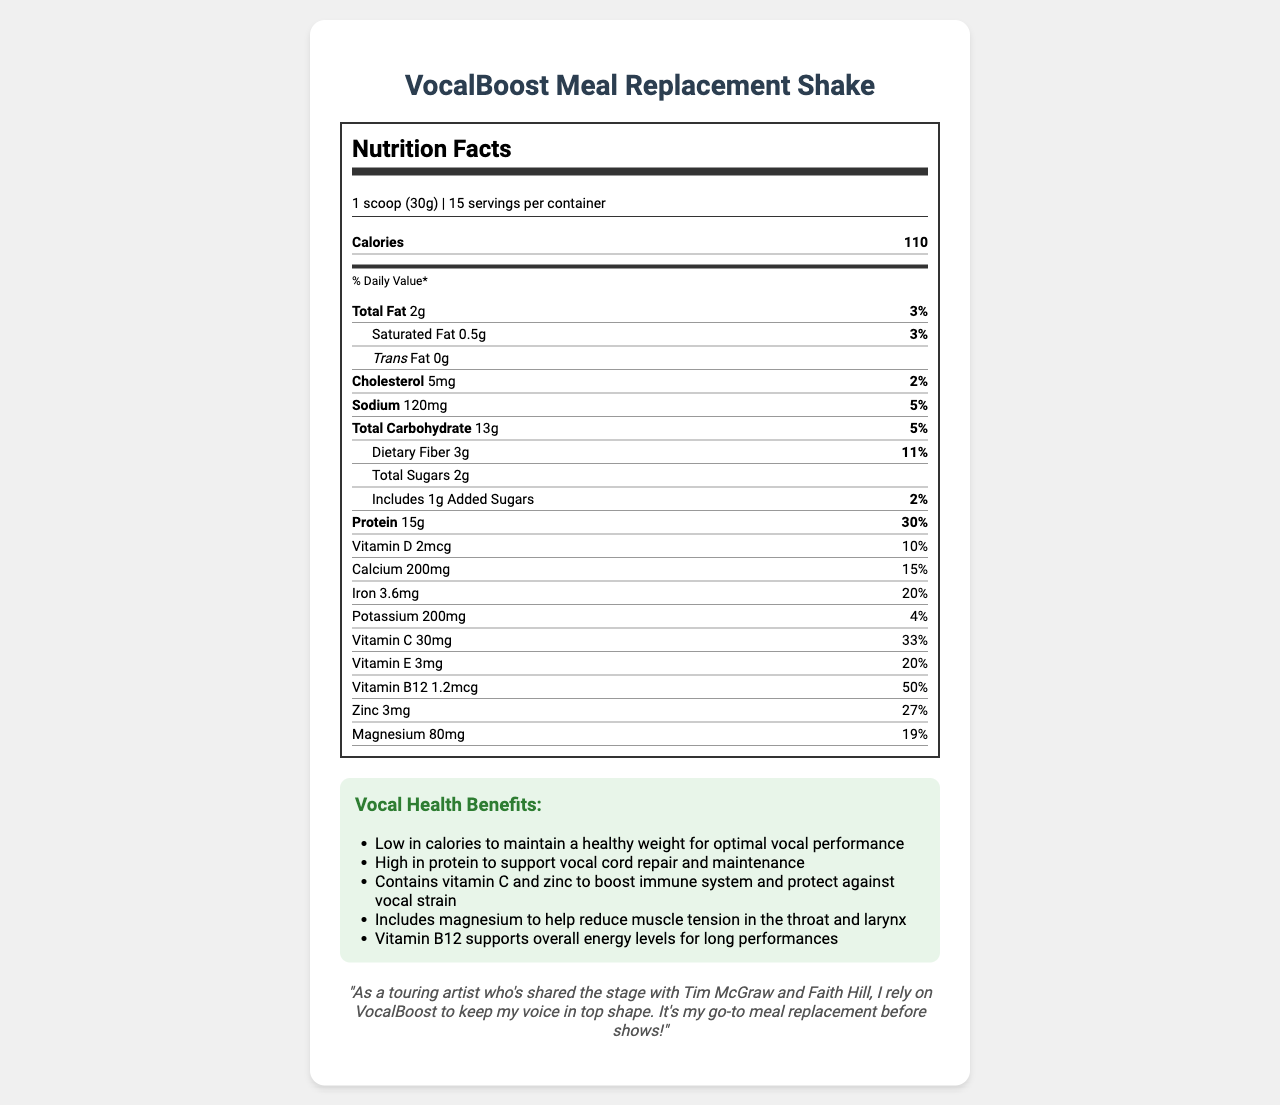what is the product name? The product name is clearly stated at the beginning of the document.
Answer: VocalBoost Meal Replacement Shake how many servings are in each container? The document specifies that there are 15 servings per container.
Answer: 15 servings what is the serving size? The serving size is mentioned as "1 scoop (30g)" in the document.
Answer: 1 scoop (30g) how many calories are in one serving? The document lists 110 calories per serving.
Answer: 110 calories what is the amount of protein in one serving? The document states that there are 15 grams of protein per serving.
Answer: 15g which nutrients have daily values of 20% or more? A. Vitamin A, Vitamin B12, Calcium B. Vitamin D, Iron, Zinc C. Vitamin B12, Vitamin E, Iron, Zinc The nutrients with daily values of 20% or more are Vitamin B12 (50%), Vitamin E (20%), Iron (20%), and Zinc (27%).
Answer: C what are the main ingredients in the shake? A. Whey protein isolate, Natural flavors, Xanthan gum B. Pea protein, Stevia leaf extract, Vitamin and mineral blend C. All of the above The main ingredients listed in the document include Whey protein isolate, Pea protein, Oat fiber, Sunflower oil, Natural flavors, Stevia leaf extract, Xanthan gum, and a Vitamin and mineral blend.
Answer: C are there any allergens in the product? The document states that the product contains milk and is manufactured in a facility that also processes soy, egg, tree nuts, and wheat.
Answer: Yes what are the vocal health benefits of the shake? The document lists various vocal health benefits, including being low in calories, high in protein, containing vitamin C and zinc, including magnesium, and supporting overall energy levels with vitamin B12.
Answer: Low in calories, high in protein, contains vitamin C and zinc, includes magnesium, and supports overall energy levels with vitamin B12 how should the shake be prepared? The preparation instructions specify to mix 1 scoop with 8-10 oz of cold water or non-dairy milk and shake well.
Answer: Mix 1 scoop (30g) with 8-10 oz of cold water or non-dairy milk and shake well what is the amount of calcium per serving? The document lists the amount of calcium per serving as 200mg.
Answer: 200mg who gave a testimonial for VocalBoost Meal Replacement Shake? The document contains a testimonial from a touring artist who has shared the stage with Tim McGraw and Faith Hill.
Answer: A touring artist who shared the stage with Tim McGraw and Faith Hill what percentage of the Daily Value for fiber does one serving provide? The document indicates that one serving provides 11% of the Daily Value for dietary fiber.
Answer: 11% how much vitamin C is in one serving? The document states that there are 30mg of vitamin C per serving.
Answer: 30mg does the product contain any added sugars? The document mentions that the product includes 1g of added sugars.
Answer: Yes what is the total carbohydrate content per serving? The document states that one serving contains 13 grams of total carbohydrates.
Answer: 13g can this shake be used by someone with a nut allergy? The document mentions that the product is manufactured in a facility that processes tree nuts, but it doesn’t explicitly state if the product itself contains nuts directly.
Answer: Not enough information summarize the main idea of the document. The document describes the nutritional content, health benefits, and preparation methods for VocalBoost Meal Replacement Shake, emphasizing its specific advantages for vocal health based on its ingredients and nutrients.
Answer: VocalBoost Meal Replacement Shake is a low-calorie, high-protein shake designed to help maintain vocal stamina and support vocal health. It includes various vitamins and minerals beneficial to the immune system, muscle tension reduction, and energy levels. It contains several ingredients and allergen information, along with preparation instructions and a testimonial from a professional singer. 